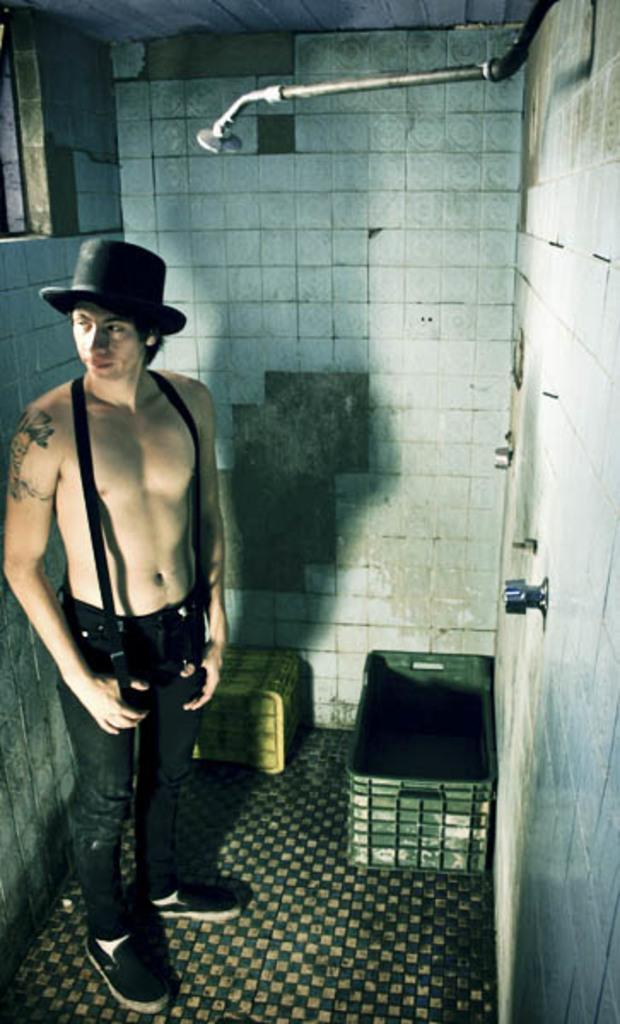What is the main subject of the image? There is a man standing in the image. Where is the man standing? The man is standing on the floor. What else can be seen in the image besides the man? There is a container, a wall, and a roof in the image. What type of shoe is the man wearing in the image? There is no information about the man's shoes in the image, so we cannot determine what type of shoe he is wearing. 